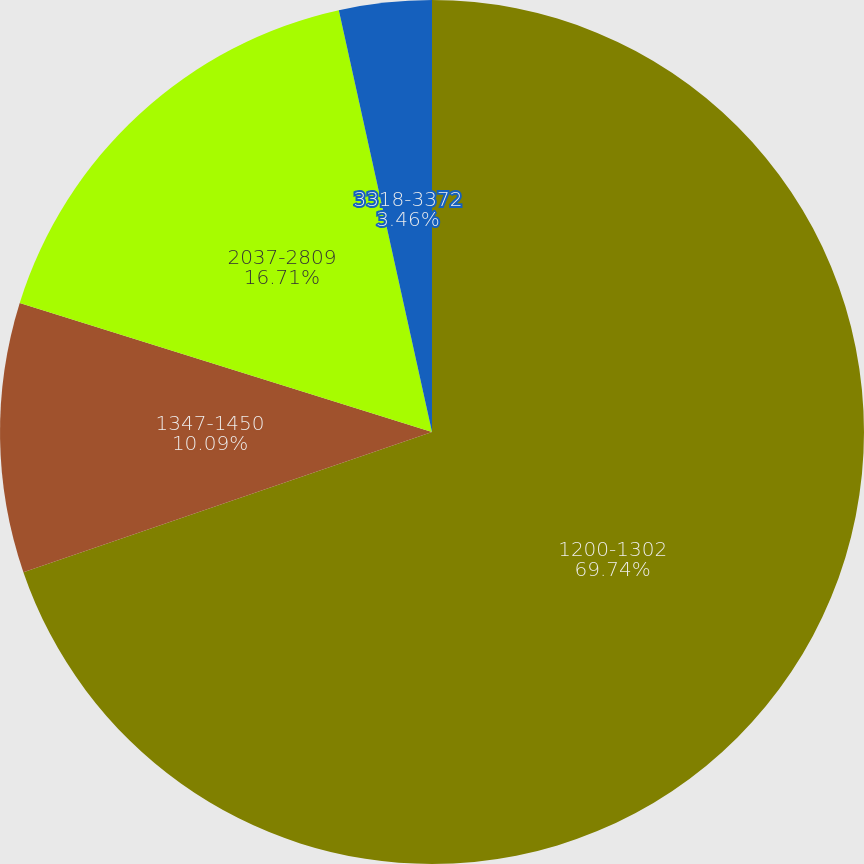<chart> <loc_0><loc_0><loc_500><loc_500><pie_chart><fcel>1200-1302<fcel>1347-1450<fcel>2037-2809<fcel>3318-3372<nl><fcel>69.74%<fcel>10.09%<fcel>16.71%<fcel>3.46%<nl></chart> 